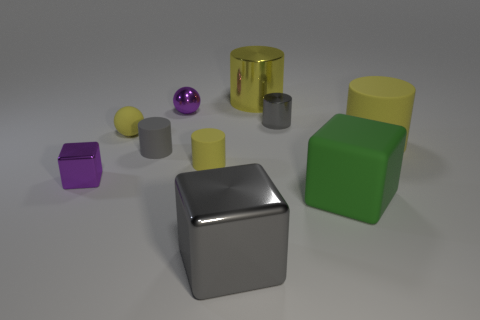Can you describe the different shapes and their colors in the image? Certainly! There's a green cube, a silver cylindrical can, a yellow cylindrical can, a purple sphere, a silver sphere, a gray cube, and a purple cube. They all have a shiny, reflective surface. 